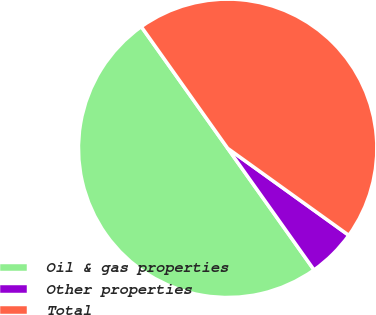Convert chart. <chart><loc_0><loc_0><loc_500><loc_500><pie_chart><fcel>Oil & gas properties<fcel>Other properties<fcel>Total<nl><fcel>50.0%<fcel>5.26%<fcel>44.74%<nl></chart> 